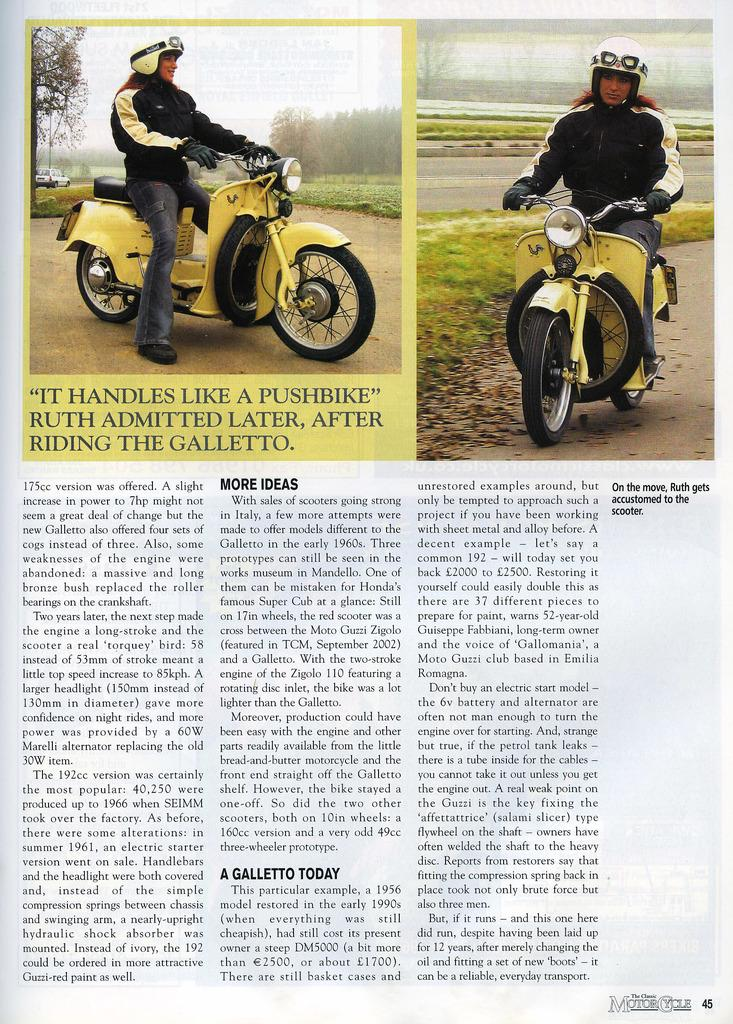What object can be seen in the image? There is a newspaper in the image. What is visible on the newspaper? There is writing on the newspaper. Can you see any giraffes or fairies in the image? No, there are no giraffes or fairies present in the image. 